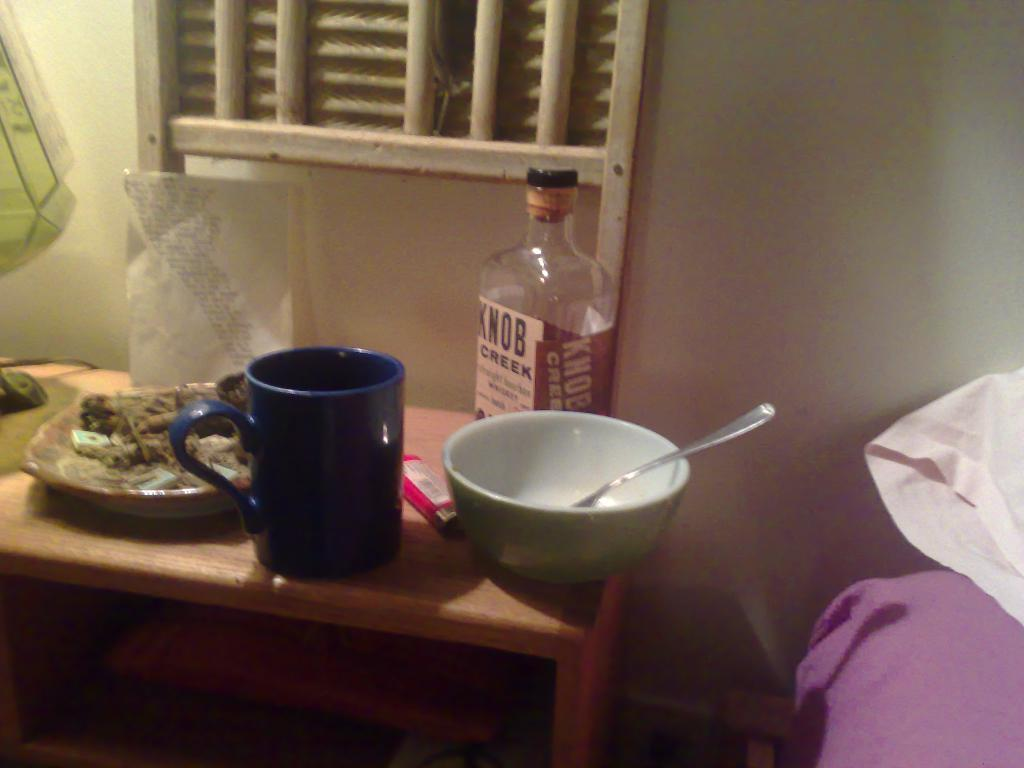<image>
Create a compact narrative representing the image presented. A bottle of Knob Creek whiskey on a table next to a bed. 